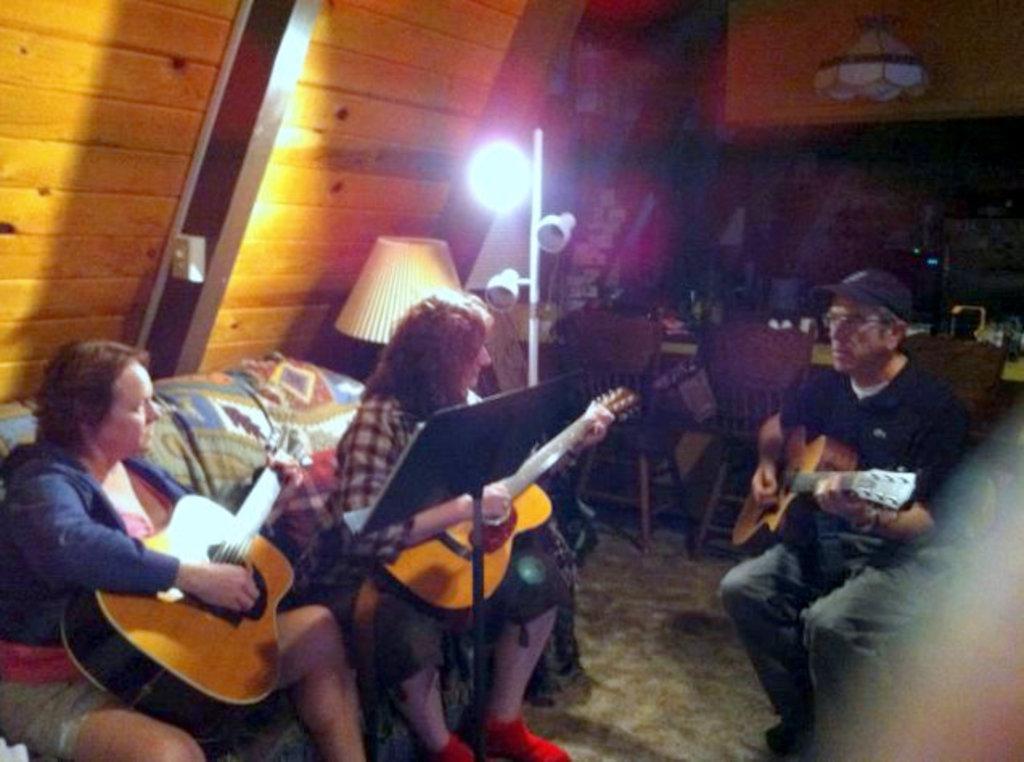Can you describe this image briefly? In the image we can see there are people who are sitting on chair and they are holding guitars in their hand. 